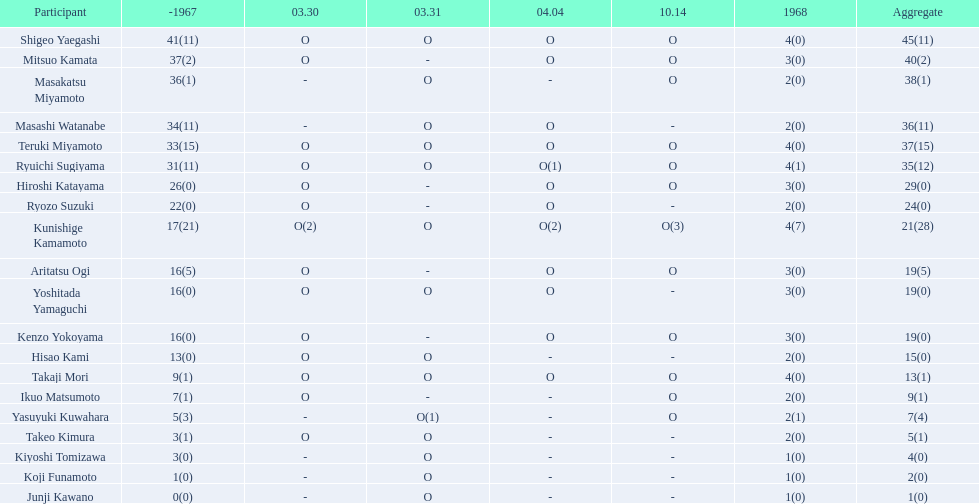Who are all of the players? Shigeo Yaegashi, Mitsuo Kamata, Masakatsu Miyamoto, Masashi Watanabe, Teruki Miyamoto, Ryuichi Sugiyama, Hiroshi Katayama, Ryozo Suzuki, Kunishige Kamamoto, Aritatsu Ogi, Yoshitada Yamaguchi, Kenzo Yokoyama, Hisao Kami, Takaji Mori, Ikuo Matsumoto, Yasuyuki Kuwahara, Takeo Kimura, Kiyoshi Tomizawa, Koji Funamoto, Junji Kawano. How many points did they receive? 45(11), 40(2), 38(1), 36(11), 37(15), 35(12), 29(0), 24(0), 21(28), 19(5), 19(0), 19(0), 15(0), 13(1), 9(1), 7(4), 5(1), 4(0), 2(0), 1(0). What about just takaji mori and junji kawano? 13(1), 1(0). I'm looking to parse the entire table for insights. Could you assist me with that? {'header': ['Participant', '-1967', '03.30', '03.31', '04.04', '10.14', '1968', 'Aggregate'], 'rows': [['Shigeo Yaegashi', '41(11)', 'O', 'O', 'O', 'O', '4(0)', '45(11)'], ['Mitsuo Kamata', '37(2)', 'O', '-', 'O', 'O', '3(0)', '40(2)'], ['Masakatsu Miyamoto', '36(1)', '-', 'O', '-', 'O', '2(0)', '38(1)'], ['Masashi Watanabe', '34(11)', '-', 'O', 'O', '-', '2(0)', '36(11)'], ['Teruki Miyamoto', '33(15)', 'O', 'O', 'O', 'O', '4(0)', '37(15)'], ['Ryuichi Sugiyama', '31(11)', 'O', 'O', 'O(1)', 'O', '4(1)', '35(12)'], ['Hiroshi Katayama', '26(0)', 'O', '-', 'O', 'O', '3(0)', '29(0)'], ['Ryozo Suzuki', '22(0)', 'O', '-', 'O', '-', '2(0)', '24(0)'], ['Kunishige Kamamoto', '17(21)', 'O(2)', 'O', 'O(2)', 'O(3)', '4(7)', '21(28)'], ['Aritatsu Ogi', '16(5)', 'O', '-', 'O', 'O', '3(0)', '19(5)'], ['Yoshitada Yamaguchi', '16(0)', 'O', 'O', 'O', '-', '3(0)', '19(0)'], ['Kenzo Yokoyama', '16(0)', 'O', '-', 'O', 'O', '3(0)', '19(0)'], ['Hisao Kami', '13(0)', 'O', 'O', '-', '-', '2(0)', '15(0)'], ['Takaji Mori', '9(1)', 'O', 'O', 'O', 'O', '4(0)', '13(1)'], ['Ikuo Matsumoto', '7(1)', 'O', '-', '-', 'O', '2(0)', '9(1)'], ['Yasuyuki Kuwahara', '5(3)', '-', 'O(1)', '-', 'O', '2(1)', '7(4)'], ['Takeo Kimura', '3(1)', 'O', 'O', '-', '-', '2(0)', '5(1)'], ['Kiyoshi Tomizawa', '3(0)', '-', 'O', '-', '-', '1(0)', '4(0)'], ['Koji Funamoto', '1(0)', '-', 'O', '-', '-', '1(0)', '2(0)'], ['Junji Kawano', '0(0)', '-', 'O', '-', '-', '1(0)', '1(0)']]} Of the two, who had more points? Takaji Mori. 